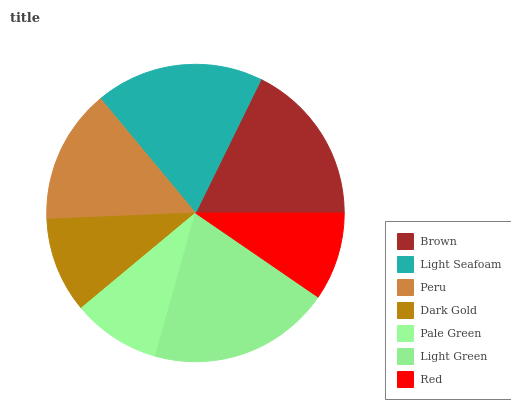Is Red the minimum?
Answer yes or no. Yes. Is Light Green the maximum?
Answer yes or no. Yes. Is Light Seafoam the minimum?
Answer yes or no. No. Is Light Seafoam the maximum?
Answer yes or no. No. Is Light Seafoam greater than Brown?
Answer yes or no. Yes. Is Brown less than Light Seafoam?
Answer yes or no. Yes. Is Brown greater than Light Seafoam?
Answer yes or no. No. Is Light Seafoam less than Brown?
Answer yes or no. No. Is Peru the high median?
Answer yes or no. Yes. Is Peru the low median?
Answer yes or no. Yes. Is Light Seafoam the high median?
Answer yes or no. No. Is Dark Gold the low median?
Answer yes or no. No. 